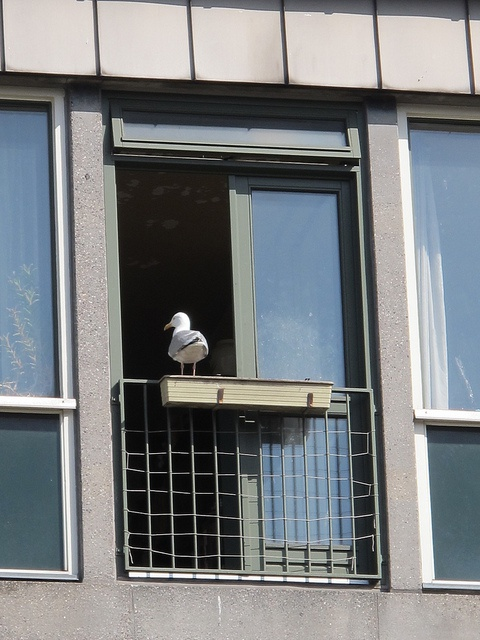Describe the objects in this image and their specific colors. I can see a bird in gray, darkgray, and lightgray tones in this image. 